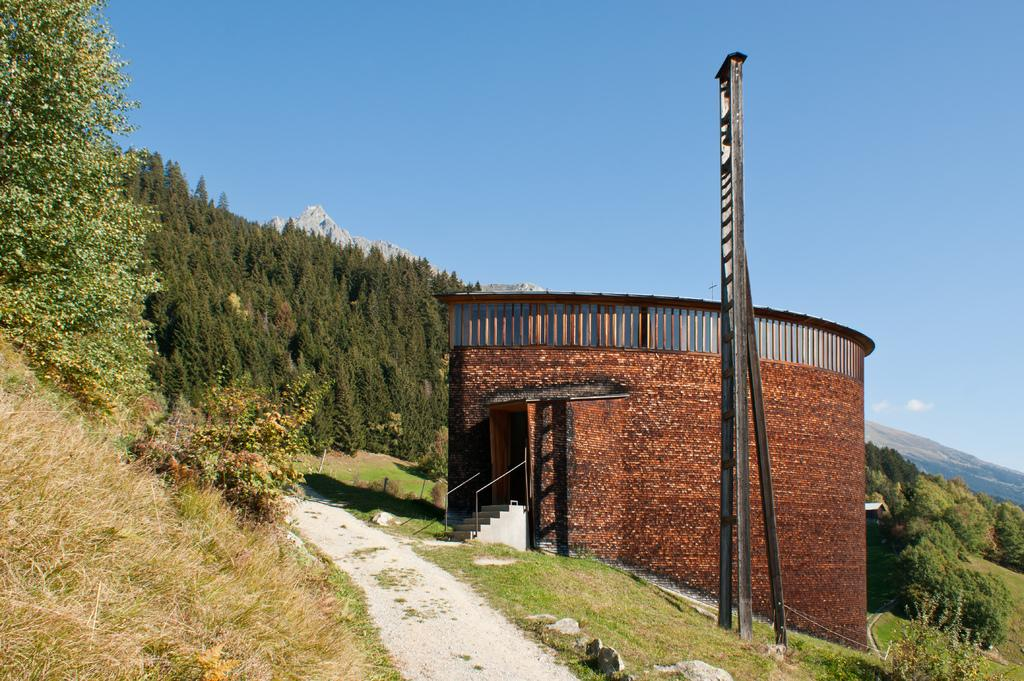What type of structure is visible in the image? There is a shed in the image. What architectural feature can be seen in the image? There are stairs in the image. What is located on the right side of the image? There is a pole on the right side of the image. What type of vegetation is at the bottom of the image? There is grass at the bottom of the image. What can be seen in the background of the image? There are trees, hills, and the sky visible in the background of the image. What language is spoken by the cactus in the image? There is no cactus present in the image, and therefore no language can be attributed to it. How many leaves are on the tree in the image? There is no tree present in the image, so it is not possible to determine the number of leaves. 